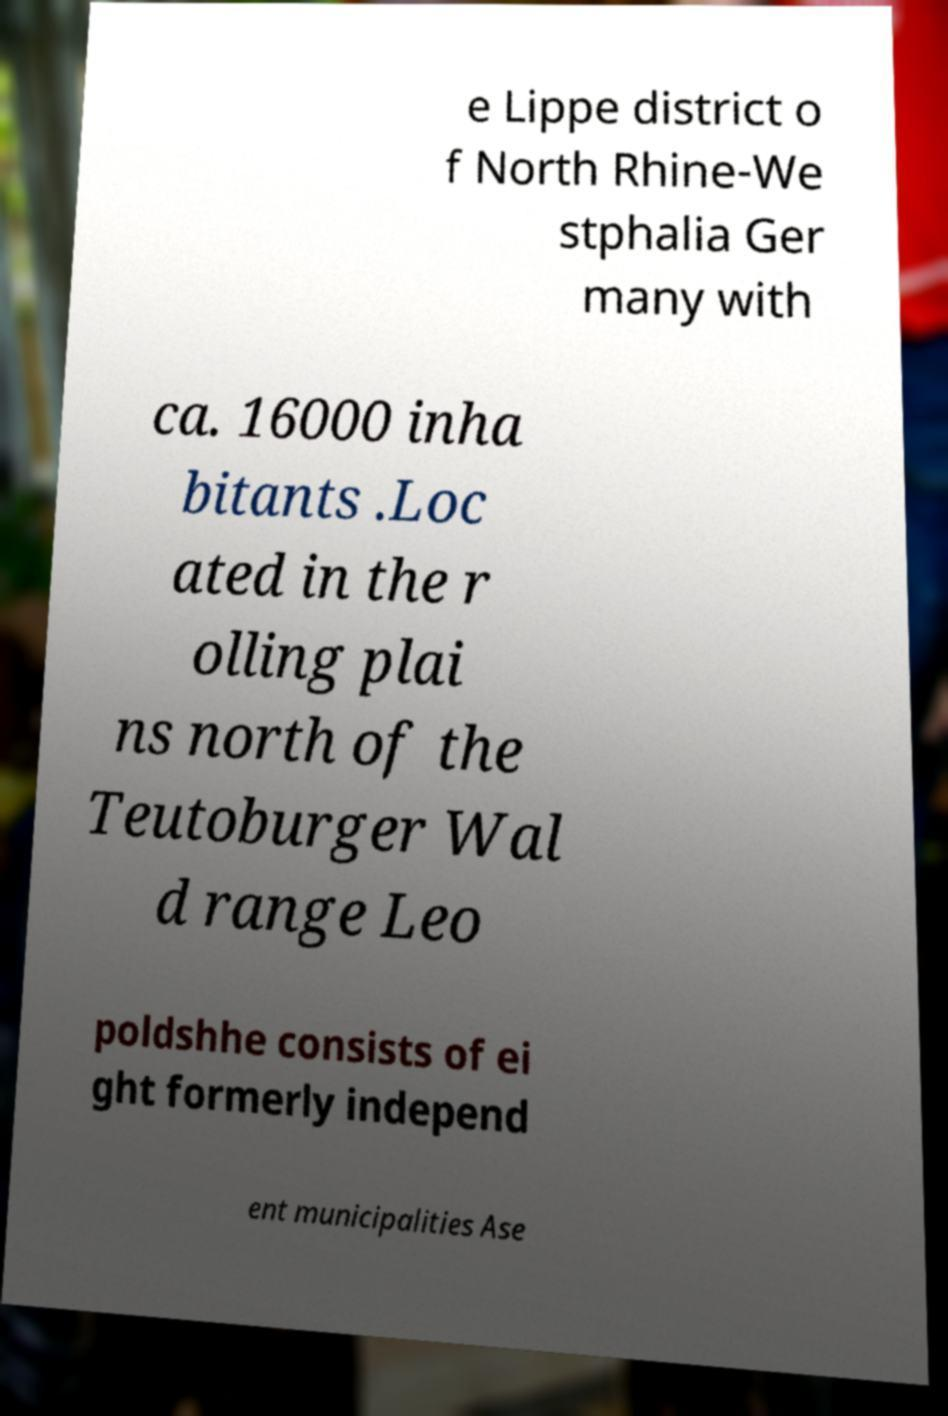Please identify and transcribe the text found in this image. e Lippe district o f North Rhine-We stphalia Ger many with ca. 16000 inha bitants .Loc ated in the r olling plai ns north of the Teutoburger Wal d range Leo poldshhe consists of ei ght formerly independ ent municipalities Ase 